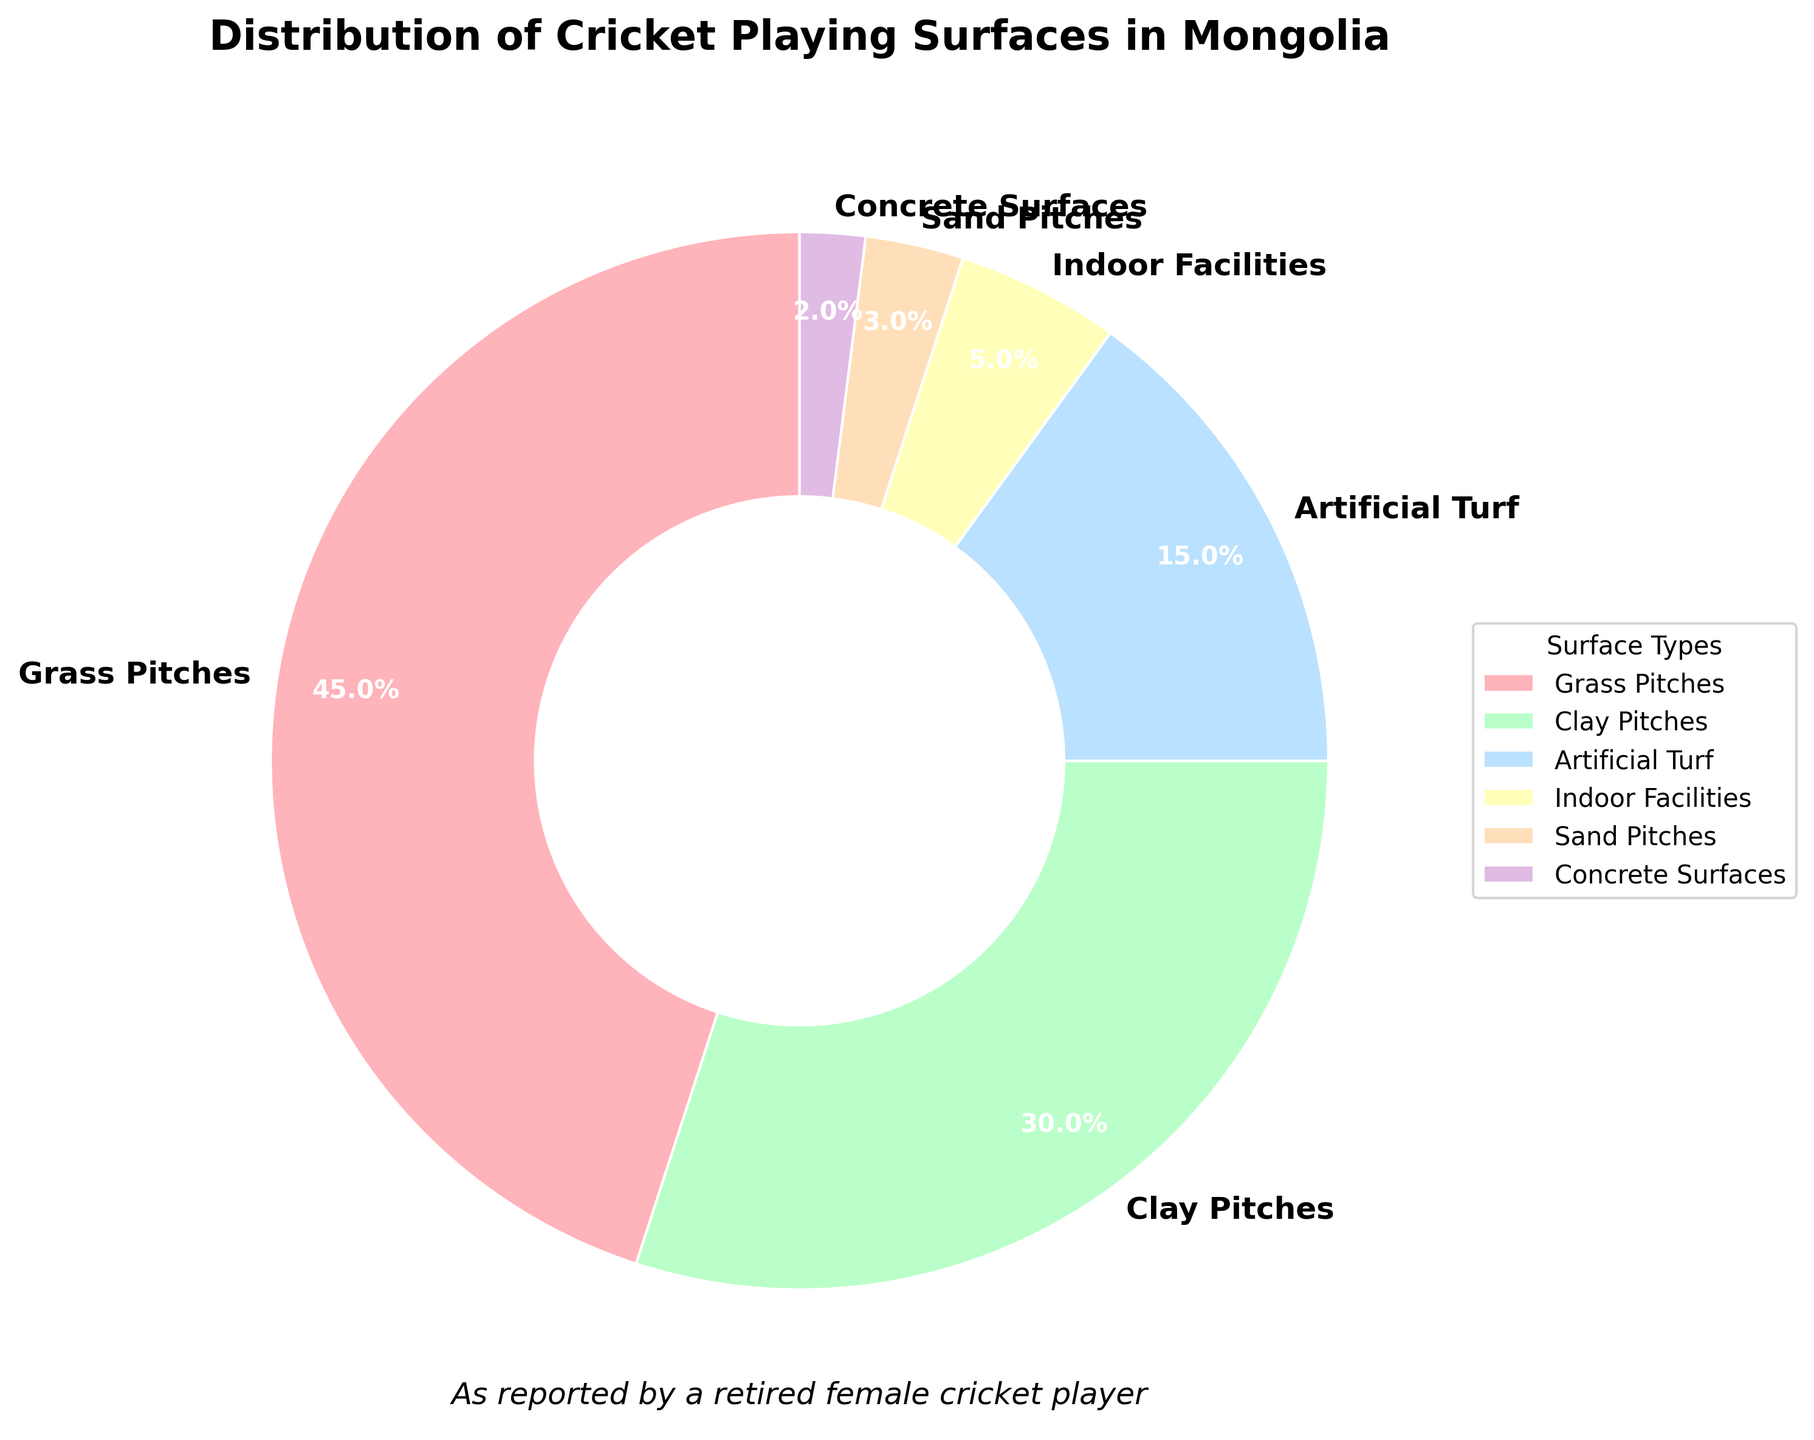What type of playing surface comprises the largest portion of the pie chart? The segment labeled "Grass Pitches" occupies the largest portion of the pie chart.
Answer: Grass Pitches Which playing surfaces together make up more than 50% of the total distribution? Grass Pitches (45%) and Clay Pitches (30%) together make up 45% + 30% = 75%, which is more than 50%.
Answer: Grass Pitches and Clay Pitches What is the combined percentage of Artificial Turf and Sand Pitches? Artificial Turf is 15% and Sand Pitches is 3%. The combined percentage is 15% + 3% = 18%.
Answer: 18% Which playing surface has the smallest representation in the pie chart? The segment labeled "Concrete Surfaces" is the smallest at 2%.
Answer: Concrete Surfaces Are Indoor Facilities used more or less than Sand Pitches for cricket in Mongolia? Indoor Facilities have a percentage of 5% while Sand Pitches have a percentage of 3%, so Indoor Facilities are used more.
Answer: More What is the difference in percentage between Grass Pitches and Artificial Turf? Grass Pitches are 45% while Artificial Turf is 15%. The difference is 45% - 15% = 30%.
Answer: 30% If you combine the percentages of the three least used surfaces, Indoor Facilities, Sand Pitches, and Concrete Surfaces, what percentage do they total? Indoor Facilities (5%) + Sand Pitches (3%) + Concrete Surfaces (2%) gives 5% + 3% + 2% = 10%.
Answer: 10% How do Clay Pitches compare to Artificial Turf in terms of usage percentage? Clay Pitches have 30% compared to Artificial Turf's 15%, which means Clay Pitches are used more.
Answer: Clay Pitches are used more What color is the segment that represents Clay Pitches in the pie chart? The segment representing Clay Pitches is colored in green.
Answer: Green 